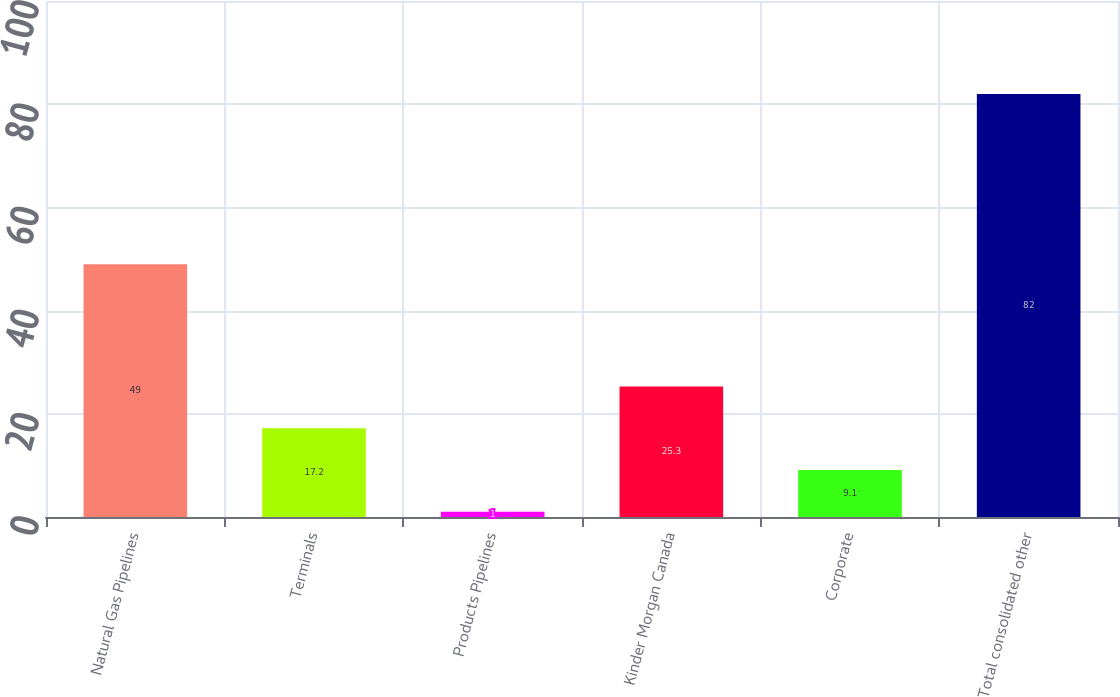Convert chart. <chart><loc_0><loc_0><loc_500><loc_500><bar_chart><fcel>Natural Gas Pipelines<fcel>Terminals<fcel>Products Pipelines<fcel>Kinder Morgan Canada<fcel>Corporate<fcel>Total consolidated other<nl><fcel>49<fcel>17.2<fcel>1<fcel>25.3<fcel>9.1<fcel>82<nl></chart> 